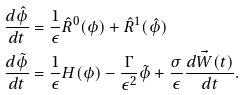Convert formula to latex. <formula><loc_0><loc_0><loc_500><loc_500>\frac { d \hat { \phi } } { d t } & = \frac { 1 } { \epsilon } \hat { R } ^ { 0 } ( \phi ) + \hat { R } ^ { 1 } ( \hat { \phi } ) \\ \frac { d \tilde { \phi } } { d t } & = \frac { 1 } { \epsilon } H ( \phi ) - \frac { \Gamma } { { \epsilon } ^ { 2 } } \tilde { \phi } + \frac { \sigma } { \epsilon } \frac { d \vec { W } ( t ) } { d t } .</formula> 